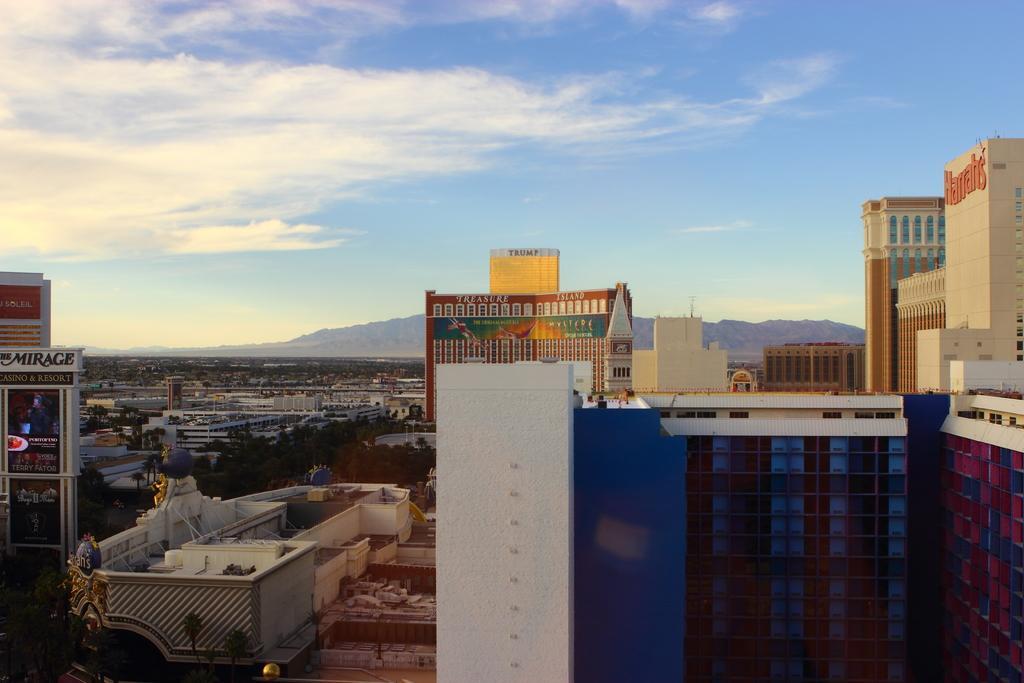In one or two sentences, can you explain what this image depicts? This picture shows the aerial view. There are so many buildings, mountains, some text on the buildings, so many name boards on the buildings and so many trees. One big colorful building is there and at the top there is the sky. 